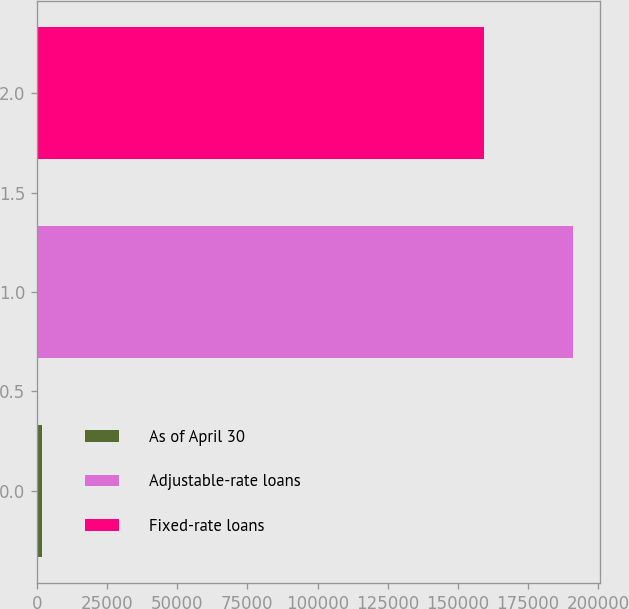Convert chart. <chart><loc_0><loc_0><loc_500><loc_500><bar_chart><fcel>As of April 30<fcel>Adjustable-rate loans<fcel>Fixed-rate loans<nl><fcel>2013<fcel>191093<fcel>159142<nl></chart> 